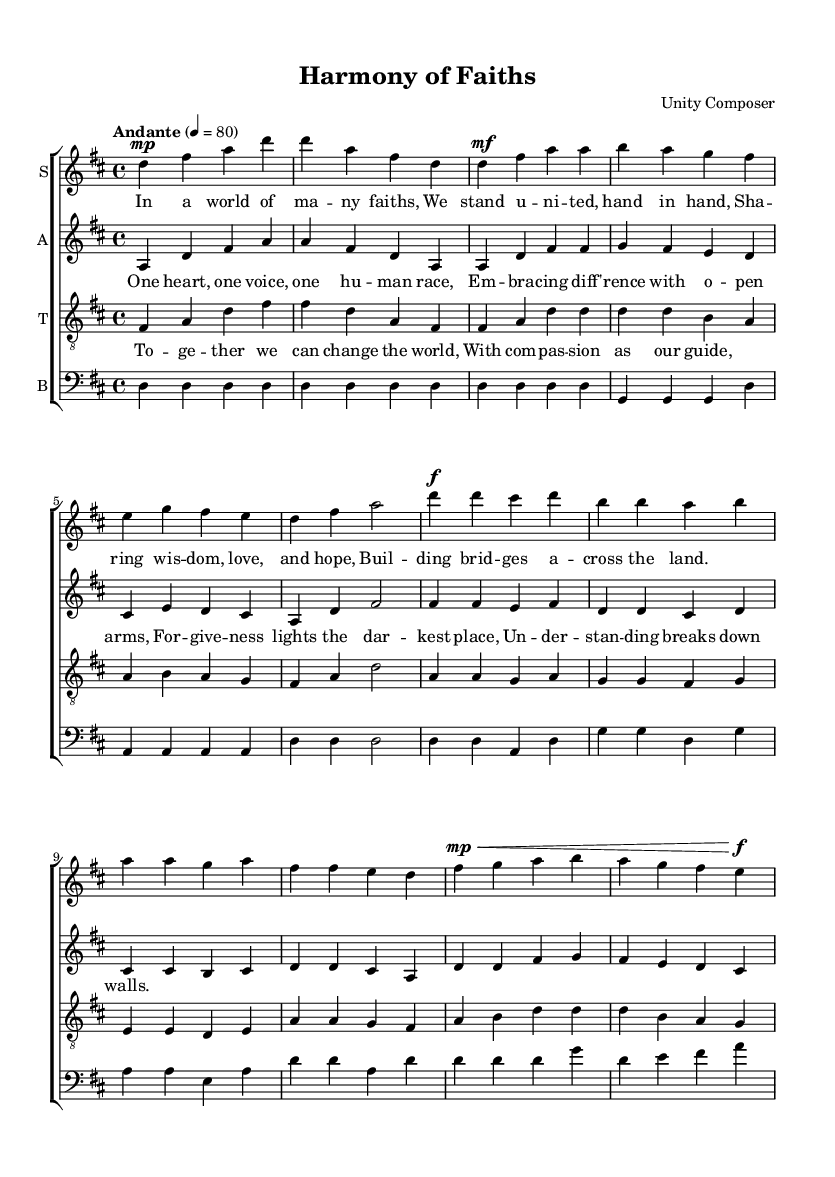What is the key signature of this music? The key signature is D major, which has two sharps (F# and C#) indicated at the beginning of each staff.
Answer: D major What is the time signature of this music? The time signature is 4/4, which is indicated directly in the music score above the notes.
Answer: 4/4 What is the tempo marking for this piece? The tempo marking is "Andante," which suggests a moderate walking pace for the performance.
Answer: Andante How many vocal parts are written in the score? There are four vocal parts: soprano, alto, tenor, and bass, each represented with a separate staff.
Answer: Four What is the primary theme of the lyrics in the chorus? The primary theme is unity and forgiveness, emphasizing collective humanity and understanding among differences.
Answer: Unity and forgiveness Which voice sings the bridge lyrics? The tenor voice sings the bridge lyrics, as indicated by the lyrics attached to the tenor staff.
Answer: Tenor What is the dynamic marking for the chorus section? The dynamic marking for the chorus section is fortissimo, indicating a loud and powerful expression in the performance.
Answer: Fortissimo 